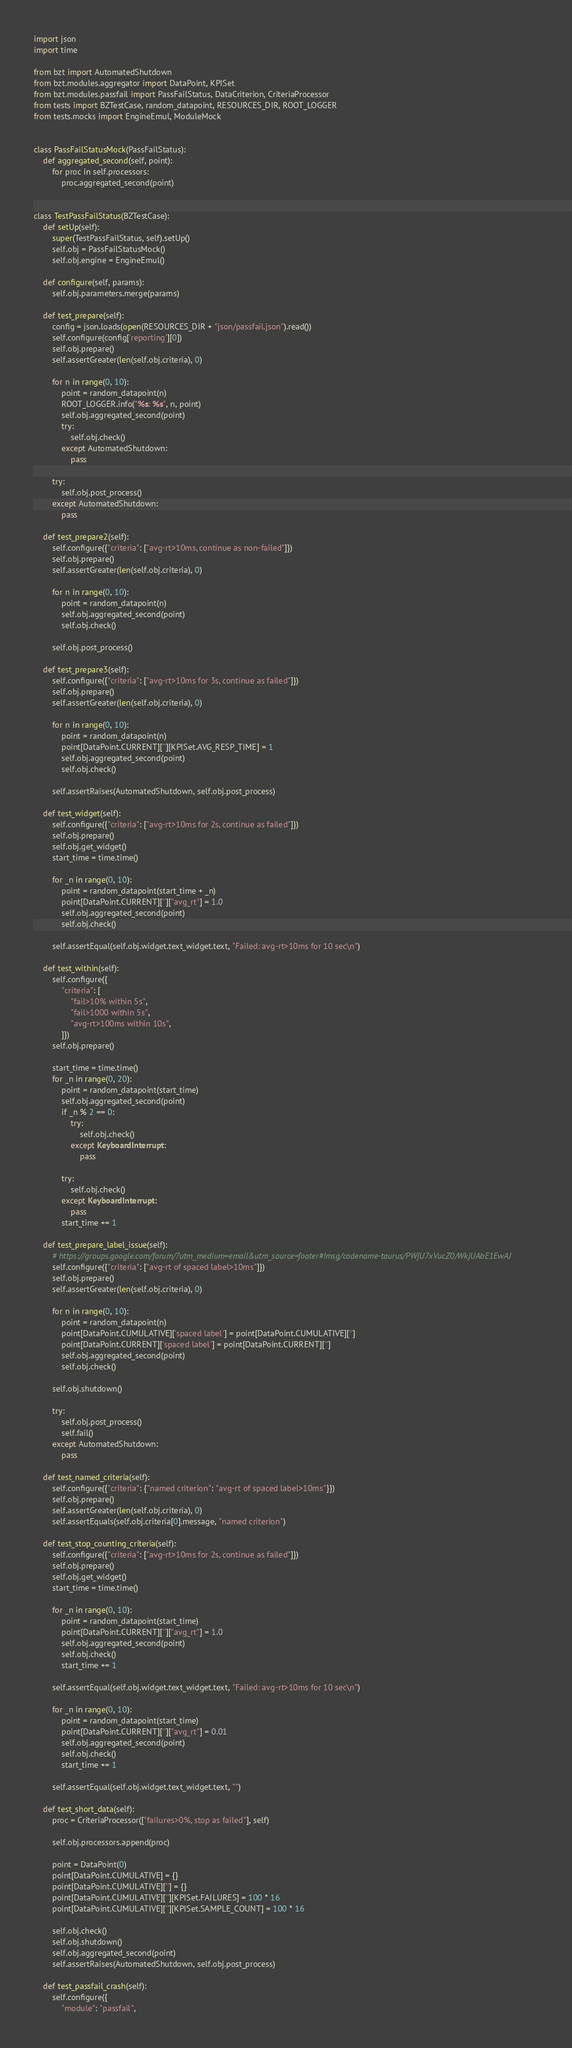<code> <loc_0><loc_0><loc_500><loc_500><_Python_>import json
import time

from bzt import AutomatedShutdown
from bzt.modules.aggregator import DataPoint, KPISet
from bzt.modules.passfail import PassFailStatus, DataCriterion, CriteriaProcessor
from tests import BZTestCase, random_datapoint, RESOURCES_DIR, ROOT_LOGGER
from tests.mocks import EngineEmul, ModuleMock


class PassFailStatusMock(PassFailStatus):
    def aggregated_second(self, point):
        for proc in self.processors:
            proc.aggregated_second(point)


class TestPassFailStatus(BZTestCase):
    def setUp(self):
        super(TestPassFailStatus, self).setUp()
        self.obj = PassFailStatusMock()
        self.obj.engine = EngineEmul()

    def configure(self, params):
        self.obj.parameters.merge(params)

    def test_prepare(self):
        config = json.loads(open(RESOURCES_DIR + "json/passfail.json").read())
        self.configure(config['reporting'][0])
        self.obj.prepare()
        self.assertGreater(len(self.obj.criteria), 0)

        for n in range(0, 10):
            point = random_datapoint(n)
            ROOT_LOGGER.info("%s: %s", n, point)
            self.obj.aggregated_second(point)
            try:
                self.obj.check()
            except AutomatedShutdown:
                pass

        try:
            self.obj.post_process()
        except AutomatedShutdown:
            pass

    def test_prepare2(self):
        self.configure({"criteria": ["avg-rt>10ms, continue as non-failed"]})
        self.obj.prepare()
        self.assertGreater(len(self.obj.criteria), 0)

        for n in range(0, 10):
            point = random_datapoint(n)
            self.obj.aggregated_second(point)
            self.obj.check()

        self.obj.post_process()

    def test_prepare3(self):
        self.configure({"criteria": ["avg-rt>10ms for 3s, continue as failed"]})
        self.obj.prepare()
        self.assertGreater(len(self.obj.criteria), 0)

        for n in range(0, 10):
            point = random_datapoint(n)
            point[DataPoint.CURRENT][''][KPISet.AVG_RESP_TIME] = 1
            self.obj.aggregated_second(point)
            self.obj.check()

        self.assertRaises(AutomatedShutdown, self.obj.post_process)

    def test_widget(self):
        self.configure({"criteria": ["avg-rt>10ms for 2s, continue as failed"]})
        self.obj.prepare()
        self.obj.get_widget()
        start_time = time.time()

        for _n in range(0, 10):
            point = random_datapoint(start_time + _n)
            point[DataPoint.CURRENT]['']["avg_rt"] = 1.0
            self.obj.aggregated_second(point)
            self.obj.check()

        self.assertEqual(self.obj.widget.text_widget.text, "Failed: avg-rt>10ms for 10 sec\n")

    def test_within(self):
        self.configure({
            "criteria": [
                "fail>10% within 5s",
                "fail>1000 within 5s",
                "avg-rt>100ms within 10s",
            ]})
        self.obj.prepare()

        start_time = time.time()
        for _n in range(0, 20):
            point = random_datapoint(start_time)
            self.obj.aggregated_second(point)
            if _n % 2 == 0:
                try:
                    self.obj.check()
                except KeyboardInterrupt:
                    pass

            try:
                self.obj.check()
            except KeyboardInterrupt:
                pass
            start_time += 1

    def test_prepare_label_issue(self):
        # https://groups.google.com/forum/?utm_medium=email&utm_source=footer#!msg/codename-taurus/PWjU7xVucZ0/WkjUAbE1EwAJ
        self.configure({"criteria": ["avg-rt of spaced label>10ms"]})
        self.obj.prepare()
        self.assertGreater(len(self.obj.criteria), 0)

        for n in range(0, 10):
            point = random_datapoint(n)
            point[DataPoint.CUMULATIVE]['spaced label'] = point[DataPoint.CUMULATIVE]['']
            point[DataPoint.CURRENT]['spaced label'] = point[DataPoint.CURRENT]['']
            self.obj.aggregated_second(point)
            self.obj.check()

        self.obj.shutdown()

        try:
            self.obj.post_process()
            self.fail()
        except AutomatedShutdown:
            pass

    def test_named_criteria(self):
        self.configure({"criteria": {"named criterion": "avg-rt of spaced label>10ms"}})
        self.obj.prepare()
        self.assertGreater(len(self.obj.criteria), 0)
        self.assertEquals(self.obj.criteria[0].message, "named criterion")

    def test_stop_counting_criteria(self):
        self.configure({"criteria": ["avg-rt>10ms for 2s, continue as failed"]})
        self.obj.prepare()
        self.obj.get_widget()
        start_time = time.time()

        for _n in range(0, 10):
            point = random_datapoint(start_time)
            point[DataPoint.CURRENT]['']["avg_rt"] = 1.0
            self.obj.aggregated_second(point)
            self.obj.check()
            start_time += 1

        self.assertEqual(self.obj.widget.text_widget.text, "Failed: avg-rt>10ms for 10 sec\n")

        for _n in range(0, 10):
            point = random_datapoint(start_time)
            point[DataPoint.CURRENT]['']["avg_rt"] = 0.01
            self.obj.aggregated_second(point)
            self.obj.check()
            start_time += 1

        self.assertEqual(self.obj.widget.text_widget.text, "")

    def test_short_data(self):
        proc = CriteriaProcessor(["failures>0%, stop as failed"], self)

        self.obj.processors.append(proc)

        point = DataPoint(0)
        point[DataPoint.CUMULATIVE] = {}
        point[DataPoint.CUMULATIVE][''] = {}
        point[DataPoint.CUMULATIVE][''][KPISet.FAILURES] = 100 * 16
        point[DataPoint.CUMULATIVE][''][KPISet.SAMPLE_COUNT] = 100 * 16

        self.obj.check()
        self.obj.shutdown()
        self.obj.aggregated_second(point)
        self.assertRaises(AutomatedShutdown, self.obj.post_process)

    def test_passfail_crash(self):
        self.configure({
            "module": "passfail",</code> 